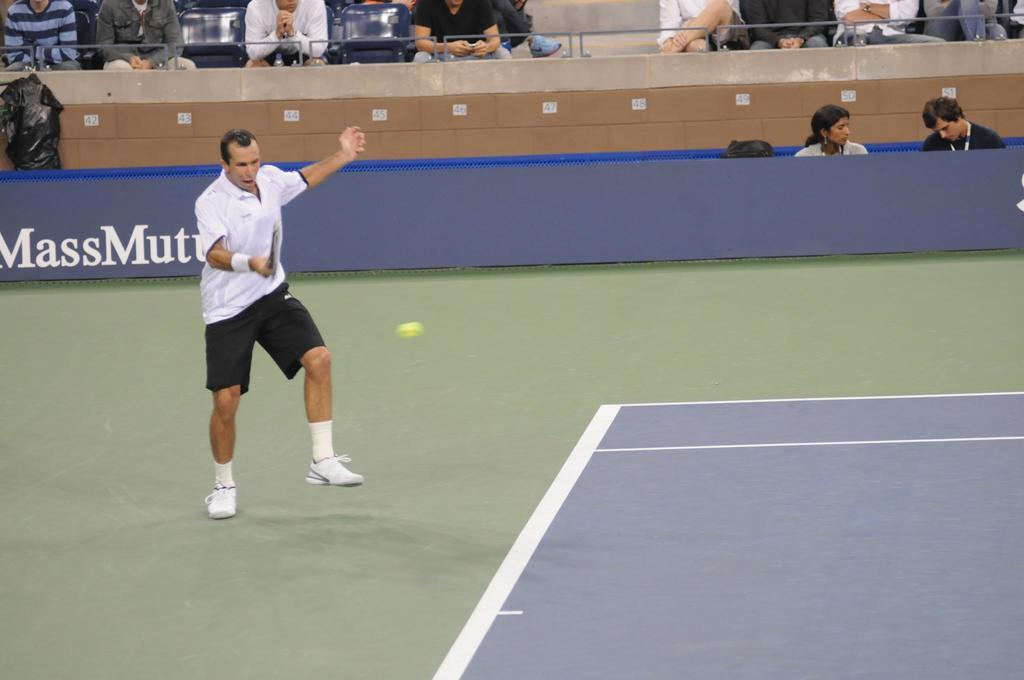Where is the image taken? The image is taken on a court. What activity is the man in the image engaged in? The man is playing badminton in the image. How is the man playing badminton? The man is standing while playing badminton. What can be seen in the background of the image? There are people sitting on chairs in the background of the image. What are the people in the background doing? The people are watching the badminton game. What type of government is depicted in the image? There is no depiction of a government in the image; it features a man playing badminton on a court. Are there any fairies visible in the image? There are no fairies present in the image; it shows a man playing badminton and people watching the game. 